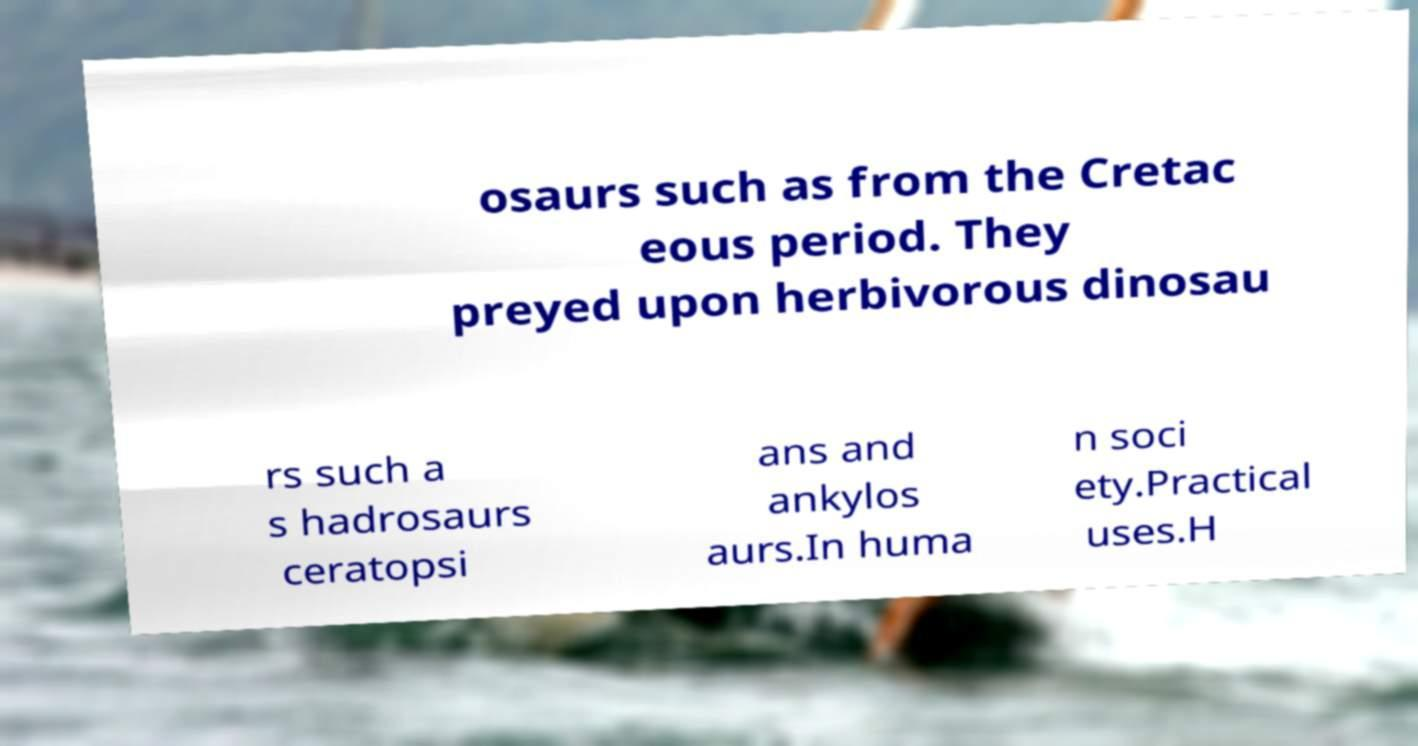There's text embedded in this image that I need extracted. Can you transcribe it verbatim? osaurs such as from the Cretac eous period. They preyed upon herbivorous dinosau rs such a s hadrosaurs ceratopsi ans and ankylos aurs.In huma n soci ety.Practical uses.H 